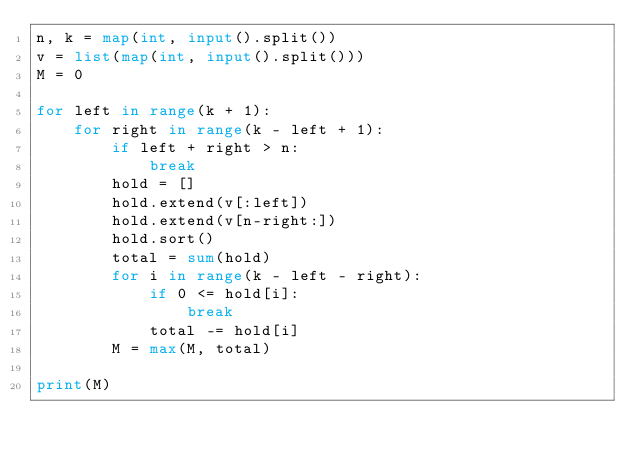<code> <loc_0><loc_0><loc_500><loc_500><_Python_>n, k = map(int, input().split())
v = list(map(int, input().split()))
M = 0

for left in range(k + 1):
    for right in range(k - left + 1):
        if left + right > n:
            break
        hold = []
        hold.extend(v[:left])
        hold.extend(v[n-right:])
        hold.sort()
        total = sum(hold)
        for i in range(k - left - right):
            if 0 <= hold[i]:
                break
            total -= hold[i]
        M = max(M, total)

print(M)

</code> 